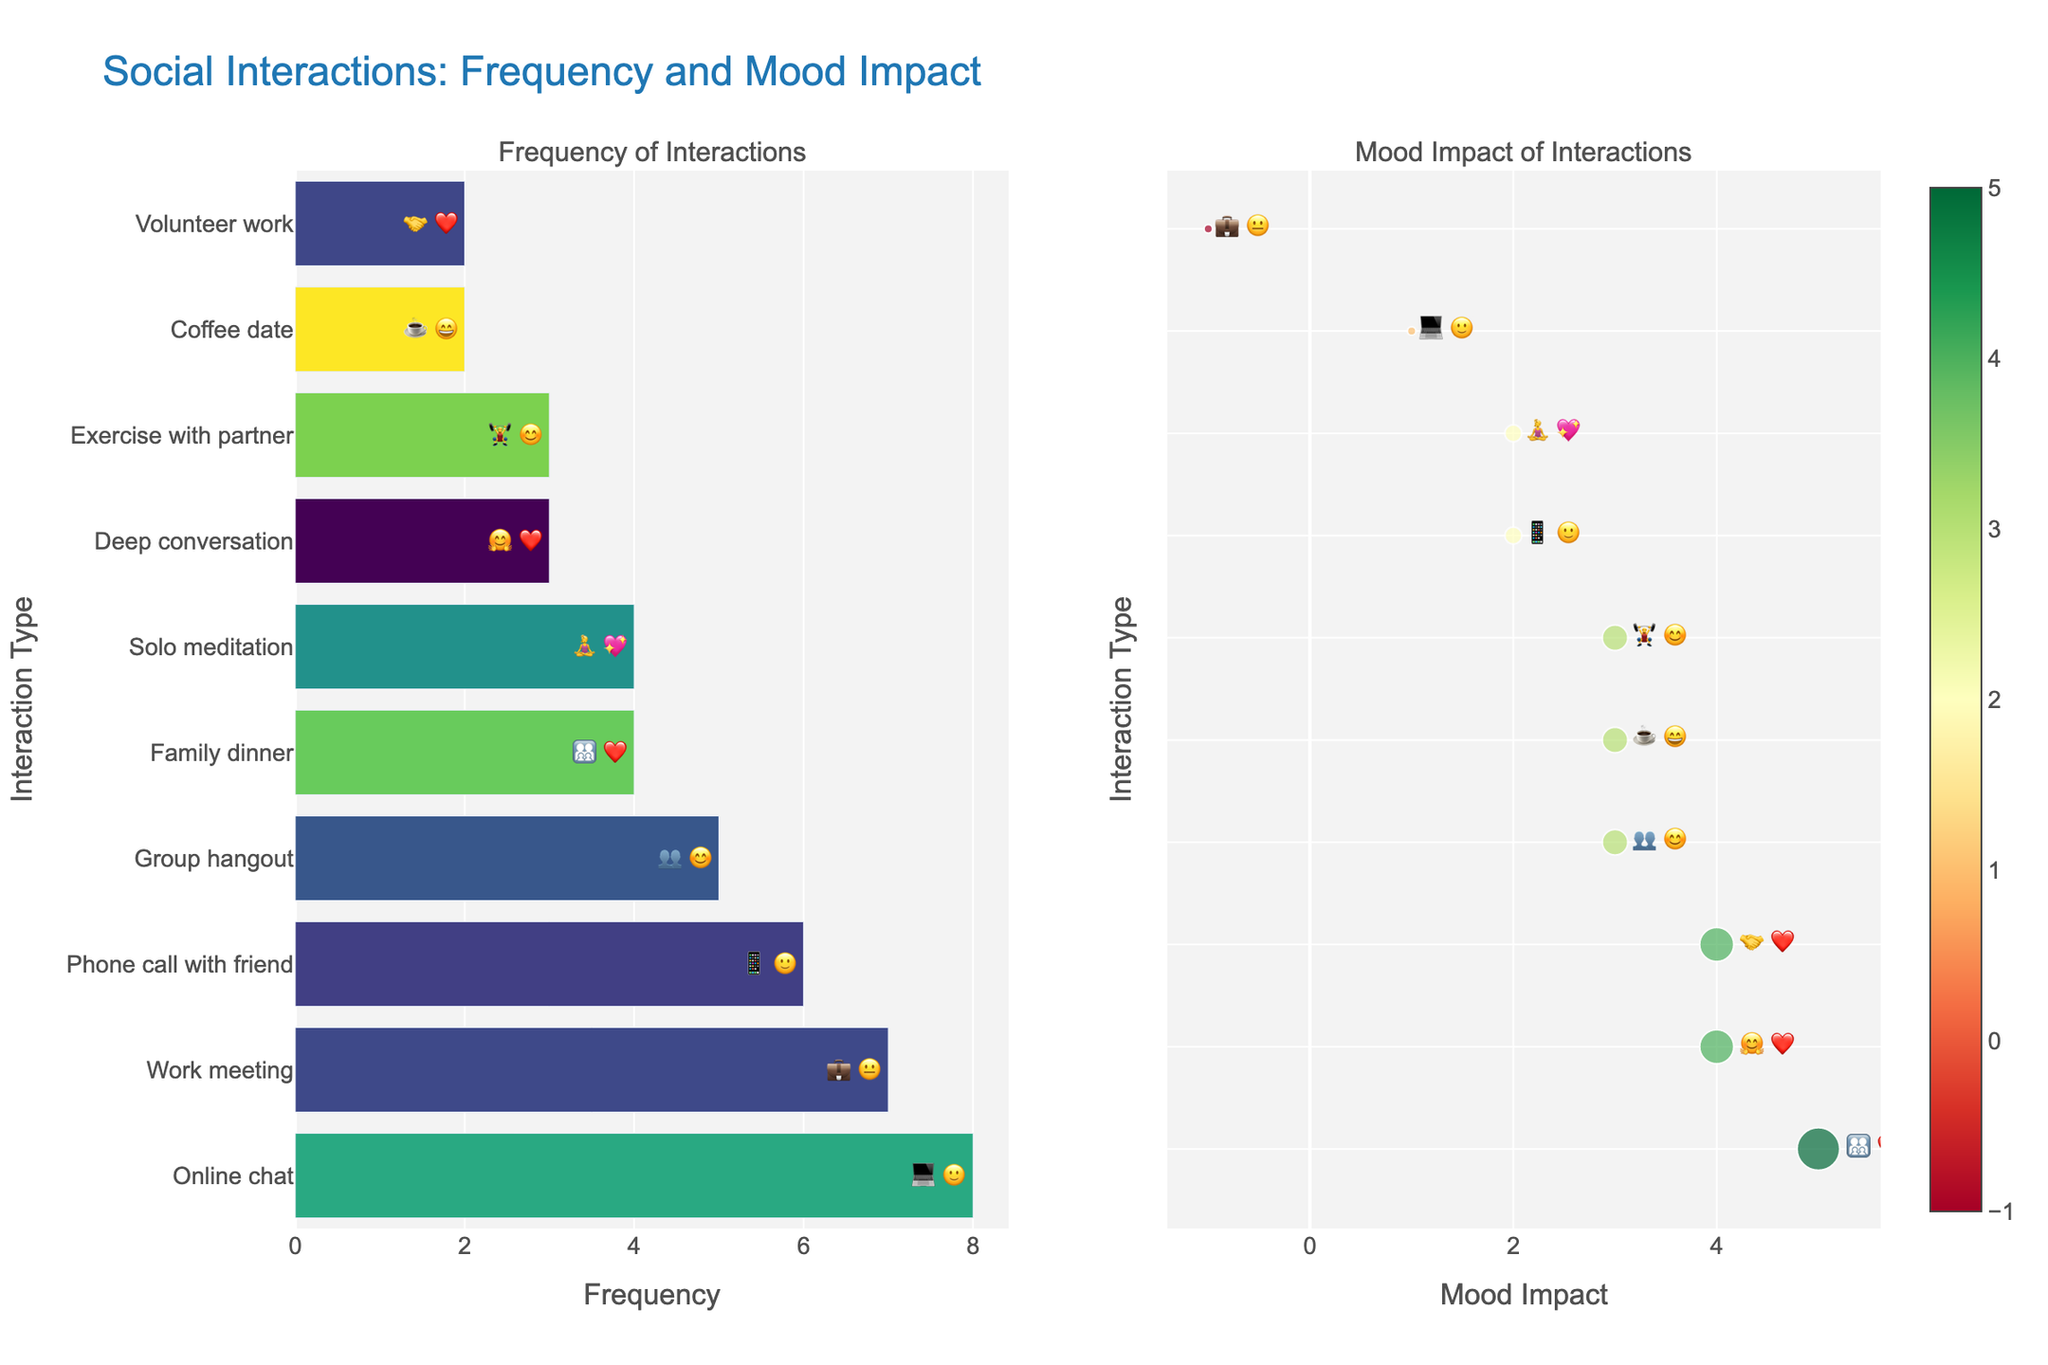what is the title of the figure? The title of the figure is written at the top and provides a summary of what the figure represents.
Answer: Social Interactions: Frequency and Mood Impact Which interaction has the highest frequency? By viewing the bar chart on the left side of the figure, observe which bar extends the furthest in the horizontal direction.
Answer: Online chat Which interaction has the lowest Mood Impact? Look at the scatter plot on the right side and find the interaction with the smallest Mood Impact value at the bottom of the y-axis.
Answer: Work meeting How many interactions have a Mood Impact of +4? In the scatter plot, count the number of markers aligned with the +4 value on the x-axis.
Answer: 3 Which interaction combines the highest frequency with a positive Mood Impact? Identify the interaction with the highest frequency bar and then check if it has a positive Mood Impact in the scatter plot.
Answer: Online chat Compare the Mood Impact of a phone call with a friend versus a group hangout. Which one is higher? Find the Mood Impact values for both interactions in the scatter plot and compare them.
Answer: Group hangout Which interaction provides the highest positive Mood Impact and what is its frequency? In the scatter plot, find the interaction with the highest positive Mood Impact, then check its frequency in the bar chart.
Answer: Family dinner, 4 How does solo meditation’s frequency and Mood Impact compare against volunteer work? Locate solo meditation and volunteer work in both plots and compare their frequencies and Mood Impacts.
Answer: Solo meditation has higher frequency (4 vs 2) and same Mood Impact (+2 vs +4) 